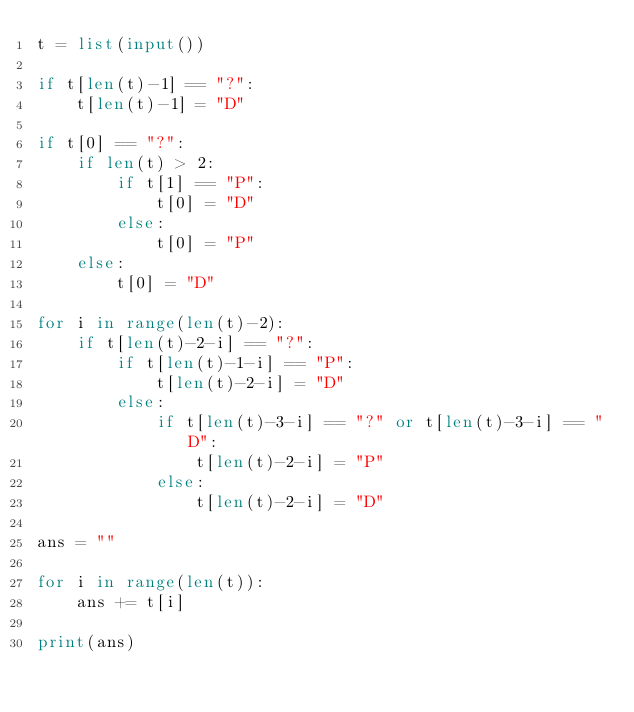Convert code to text. <code><loc_0><loc_0><loc_500><loc_500><_Python_>t = list(input())

if t[len(t)-1] == "?":
    t[len(t)-1] = "D"

if t[0] == "?":
    if len(t) > 2:
        if t[1] == "P":
            t[0] = "D"
        else:
            t[0] = "P"
    else:
        t[0] = "D"

for i in range(len(t)-2):
    if t[len(t)-2-i] == "?":
        if t[len(t)-1-i] == "P":
            t[len(t)-2-i] = "D"
        else:
            if t[len(t)-3-i] == "?" or t[len(t)-3-i] == "D":
                t[len(t)-2-i] = "P"
            else:
                t[len(t)-2-i] = "D"

ans = ""

for i in range(len(t)):
    ans += t[i]

print(ans)</code> 